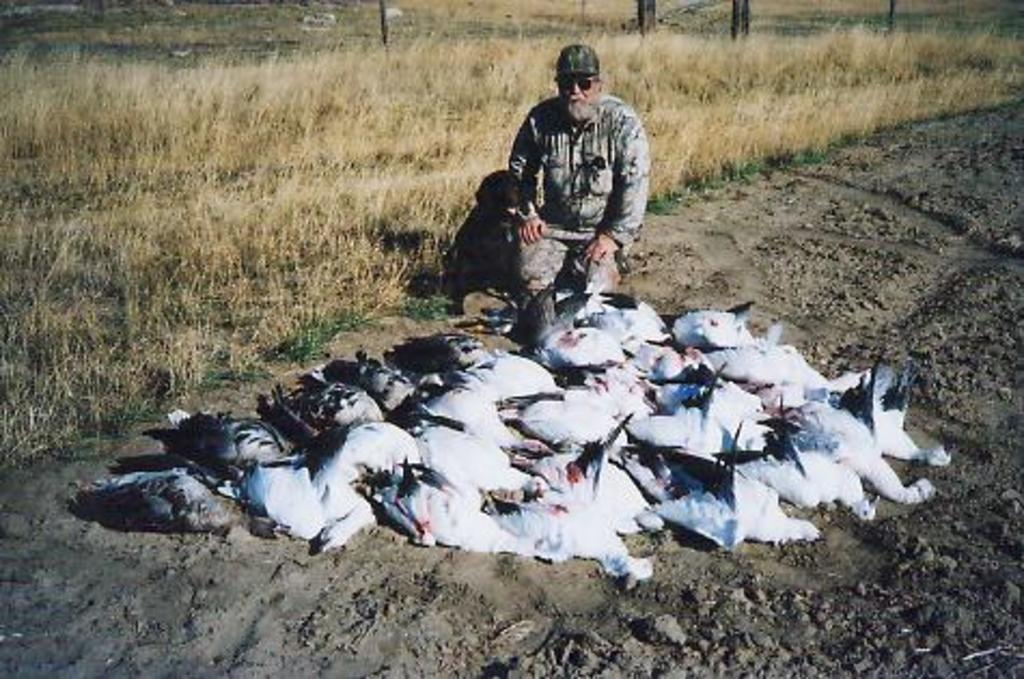What is the main subject of the image? The main subject of the image is many birds. Where are the birds located in the image? The birds are laying on a path in the image. Can you describe the person in the background of the image? There is a person in a squat position in the background of the image. What type of vegetation is present in the image? Grass is present in the image. What type of feast is being prepared by the birds in the image? There is no indication in the image that the birds are preparing a feast, as they are simply laying on a path. Can you describe the cub that is playing with the birds in the image? There is no cub present in the image; it only features birds and a person in the background. 